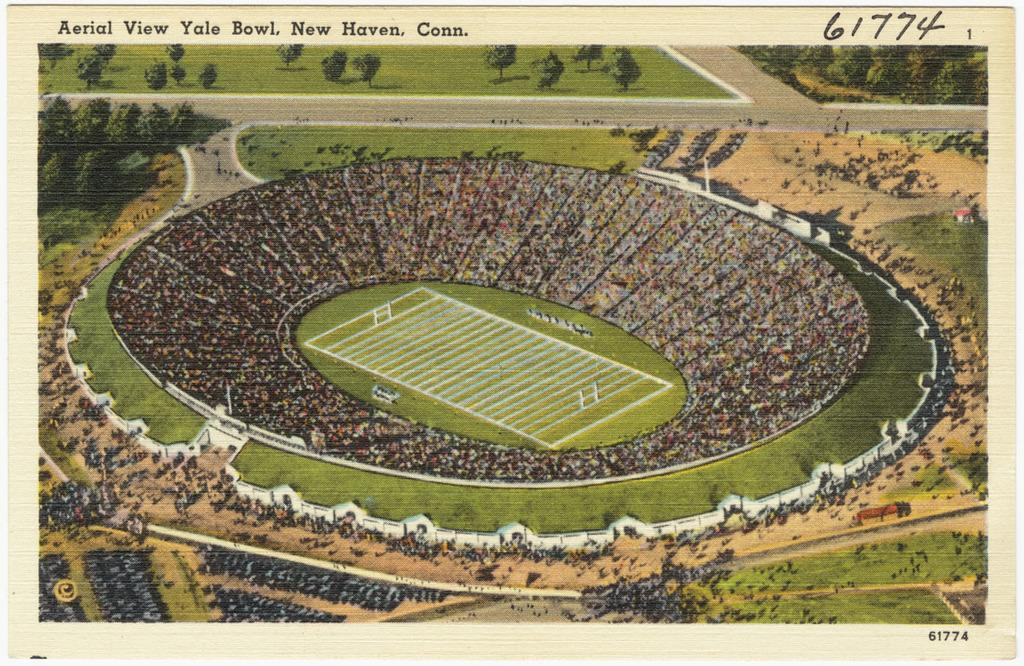What is depicted on the paper in the image? There is a picture of a stadium on a paper. What can be seen on the left side of the image? There are trees to the left of the paper. What can be seen on the right side of the image? There are trees to the right of the paper. What type of cork can be seen in the image? There is no cork present in the image. What instrument is the drummer playing in the image? There is no drummer or drum present in the image. 